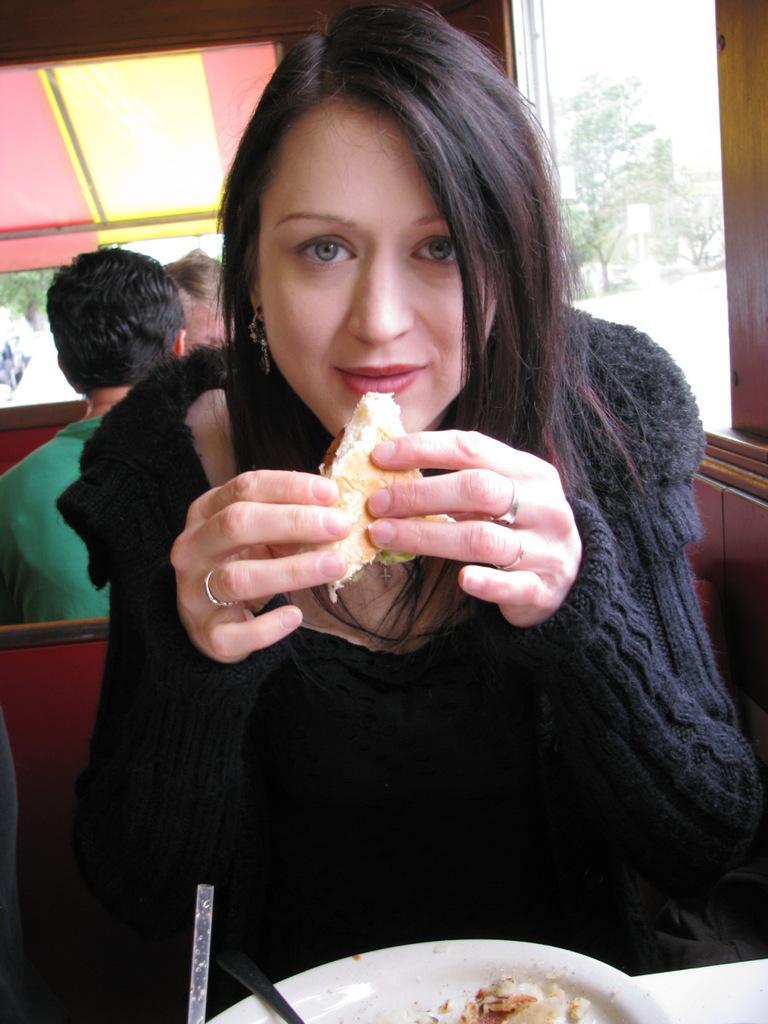In one or two sentences, can you explain what this image depicts? In this image in the foreground there is one woman who is sitting and she is holding something in her hand in font of her there is one plate. In that plate there are some spoons and food and in the background there are some people who are siting and there are some trees, tent and on the right side there is a wooden wall. 